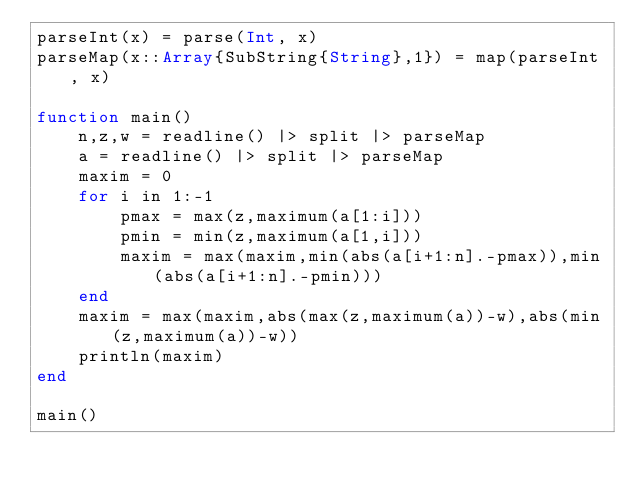Convert code to text. <code><loc_0><loc_0><loc_500><loc_500><_Julia_>parseInt(x) = parse(Int, x)
parseMap(x::Array{SubString{String},1}) = map(parseInt, x)

function main()
	n,z,w = readline() |> split |> parseMap
	a = readline() |> split |> parseMap
	maxim = 0
	for i in 1:-1
		pmax = max(z,maximum(a[1:i]))
		pmin = min(z,maximum(a[1,i]))
		maxim = max(maxim,min(abs(a[i+1:n].-pmax)),min(abs(a[i+1:n].-pmin)))
	end
	maxim = max(maxim,abs(max(z,maximum(a))-w),abs(min(z,maximum(a))-w))
	println(maxim)
end

main()
</code> 